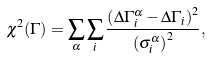<formula> <loc_0><loc_0><loc_500><loc_500>\chi ^ { 2 } ( \Gamma ) = \sum _ { \alpha } \sum _ { i } { \frac { \left ( \Delta \Gamma _ { i } ^ { \alpha } - \Delta \Gamma _ { i } \right ) ^ { 2 } } { \left ( \sigma ^ { \alpha } _ { i } \right ) ^ { 2 } } } ,</formula> 